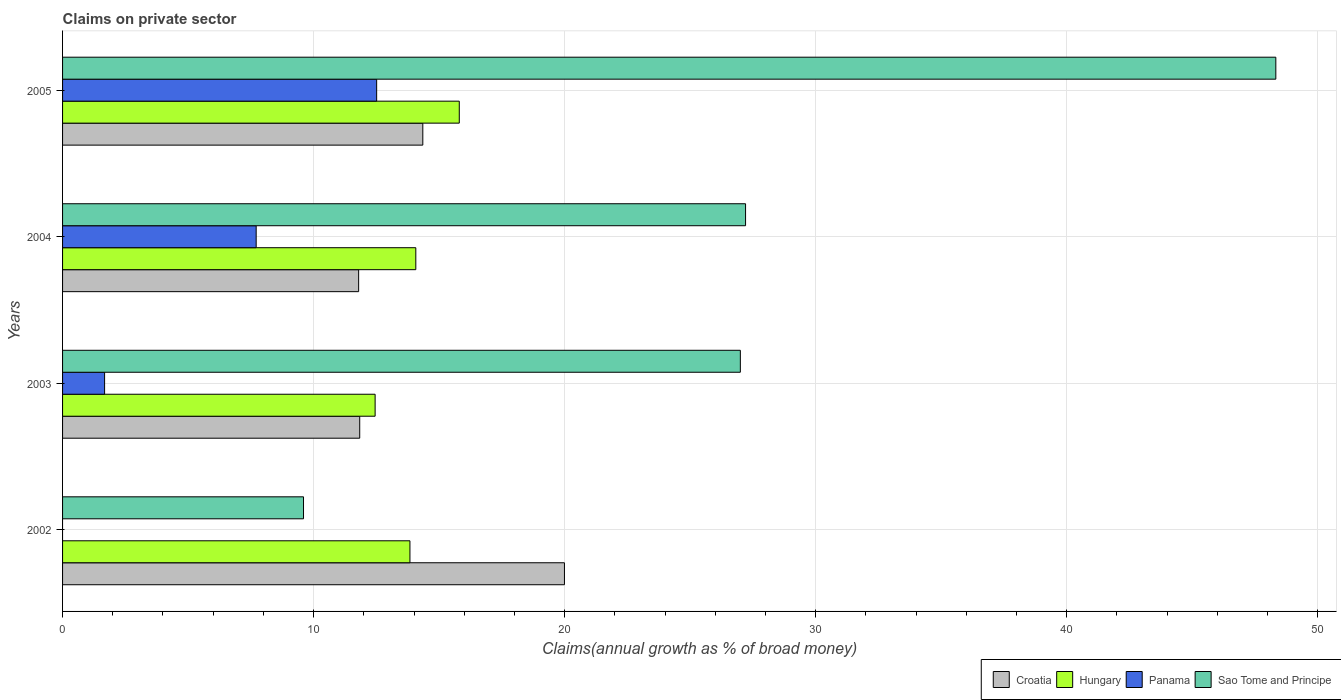Are the number of bars per tick equal to the number of legend labels?
Keep it short and to the point. No. Are the number of bars on each tick of the Y-axis equal?
Provide a succinct answer. No. How many bars are there on the 3rd tick from the bottom?
Your answer should be very brief. 4. What is the percentage of broad money claimed on private sector in Sao Tome and Principe in 2005?
Give a very brief answer. 48.33. Across all years, what is the maximum percentage of broad money claimed on private sector in Croatia?
Offer a very short reply. 19.99. Across all years, what is the minimum percentage of broad money claimed on private sector in Croatia?
Your response must be concise. 11.8. In which year was the percentage of broad money claimed on private sector in Croatia maximum?
Your answer should be compact. 2002. What is the total percentage of broad money claimed on private sector in Hungary in the graph?
Offer a terse response. 56.17. What is the difference between the percentage of broad money claimed on private sector in Panama in 2004 and that in 2005?
Keep it short and to the point. -4.8. What is the difference between the percentage of broad money claimed on private sector in Sao Tome and Principe in 2005 and the percentage of broad money claimed on private sector in Panama in 2002?
Offer a very short reply. 48.33. What is the average percentage of broad money claimed on private sector in Sao Tome and Principe per year?
Keep it short and to the point. 28.04. In the year 2002, what is the difference between the percentage of broad money claimed on private sector in Croatia and percentage of broad money claimed on private sector in Hungary?
Ensure brevity in your answer.  6.16. What is the ratio of the percentage of broad money claimed on private sector in Sao Tome and Principe in 2002 to that in 2005?
Provide a short and direct response. 0.2. Is the difference between the percentage of broad money claimed on private sector in Croatia in 2002 and 2004 greater than the difference between the percentage of broad money claimed on private sector in Hungary in 2002 and 2004?
Offer a very short reply. Yes. What is the difference between the highest and the second highest percentage of broad money claimed on private sector in Hungary?
Ensure brevity in your answer.  1.73. What is the difference between the highest and the lowest percentage of broad money claimed on private sector in Hungary?
Make the answer very short. 3.35. In how many years, is the percentage of broad money claimed on private sector in Sao Tome and Principe greater than the average percentage of broad money claimed on private sector in Sao Tome and Principe taken over all years?
Make the answer very short. 1. Is it the case that in every year, the sum of the percentage of broad money claimed on private sector in Panama and percentage of broad money claimed on private sector in Sao Tome and Principe is greater than the sum of percentage of broad money claimed on private sector in Croatia and percentage of broad money claimed on private sector in Hungary?
Provide a succinct answer. No. Is it the case that in every year, the sum of the percentage of broad money claimed on private sector in Hungary and percentage of broad money claimed on private sector in Sao Tome and Principe is greater than the percentage of broad money claimed on private sector in Panama?
Offer a very short reply. Yes. Are all the bars in the graph horizontal?
Make the answer very short. Yes. How many years are there in the graph?
Your answer should be very brief. 4. What is the difference between two consecutive major ticks on the X-axis?
Your answer should be compact. 10. Does the graph contain grids?
Your answer should be very brief. Yes. How many legend labels are there?
Your answer should be very brief. 4. How are the legend labels stacked?
Your answer should be very brief. Horizontal. What is the title of the graph?
Make the answer very short. Claims on private sector. What is the label or title of the X-axis?
Your answer should be compact. Claims(annual growth as % of broad money). What is the label or title of the Y-axis?
Keep it short and to the point. Years. What is the Claims(annual growth as % of broad money) in Croatia in 2002?
Offer a terse response. 19.99. What is the Claims(annual growth as % of broad money) of Hungary in 2002?
Make the answer very short. 13.84. What is the Claims(annual growth as % of broad money) in Panama in 2002?
Your answer should be compact. 0. What is the Claims(annual growth as % of broad money) of Sao Tome and Principe in 2002?
Keep it short and to the point. 9.6. What is the Claims(annual growth as % of broad money) of Croatia in 2003?
Your answer should be very brief. 11.84. What is the Claims(annual growth as % of broad money) of Hungary in 2003?
Provide a succinct answer. 12.45. What is the Claims(annual growth as % of broad money) in Panama in 2003?
Make the answer very short. 1.67. What is the Claims(annual growth as % of broad money) of Sao Tome and Principe in 2003?
Your answer should be compact. 27. What is the Claims(annual growth as % of broad money) in Croatia in 2004?
Keep it short and to the point. 11.8. What is the Claims(annual growth as % of broad money) of Hungary in 2004?
Give a very brief answer. 14.07. What is the Claims(annual growth as % of broad money) of Panama in 2004?
Ensure brevity in your answer.  7.71. What is the Claims(annual growth as % of broad money) in Sao Tome and Principe in 2004?
Make the answer very short. 27.21. What is the Claims(annual growth as % of broad money) in Croatia in 2005?
Your answer should be compact. 14.35. What is the Claims(annual growth as % of broad money) in Hungary in 2005?
Make the answer very short. 15.8. What is the Claims(annual growth as % of broad money) in Panama in 2005?
Provide a short and direct response. 12.51. What is the Claims(annual growth as % of broad money) of Sao Tome and Principe in 2005?
Provide a short and direct response. 48.33. Across all years, what is the maximum Claims(annual growth as % of broad money) of Croatia?
Offer a terse response. 19.99. Across all years, what is the maximum Claims(annual growth as % of broad money) in Hungary?
Offer a very short reply. 15.8. Across all years, what is the maximum Claims(annual growth as % of broad money) in Panama?
Provide a succinct answer. 12.51. Across all years, what is the maximum Claims(annual growth as % of broad money) in Sao Tome and Principe?
Provide a succinct answer. 48.33. Across all years, what is the minimum Claims(annual growth as % of broad money) of Croatia?
Your answer should be compact. 11.8. Across all years, what is the minimum Claims(annual growth as % of broad money) of Hungary?
Your answer should be compact. 12.45. Across all years, what is the minimum Claims(annual growth as % of broad money) in Panama?
Ensure brevity in your answer.  0. Across all years, what is the minimum Claims(annual growth as % of broad money) of Sao Tome and Principe?
Your response must be concise. 9.6. What is the total Claims(annual growth as % of broad money) in Croatia in the graph?
Ensure brevity in your answer.  57.98. What is the total Claims(annual growth as % of broad money) of Hungary in the graph?
Give a very brief answer. 56.17. What is the total Claims(annual growth as % of broad money) of Panama in the graph?
Your response must be concise. 21.9. What is the total Claims(annual growth as % of broad money) of Sao Tome and Principe in the graph?
Provide a short and direct response. 112.14. What is the difference between the Claims(annual growth as % of broad money) of Croatia in 2002 and that in 2003?
Keep it short and to the point. 8.16. What is the difference between the Claims(annual growth as % of broad money) in Hungary in 2002 and that in 2003?
Your answer should be compact. 1.39. What is the difference between the Claims(annual growth as % of broad money) of Sao Tome and Principe in 2002 and that in 2003?
Your answer should be very brief. -17.4. What is the difference between the Claims(annual growth as % of broad money) in Croatia in 2002 and that in 2004?
Provide a succinct answer. 8.2. What is the difference between the Claims(annual growth as % of broad money) in Hungary in 2002 and that in 2004?
Provide a succinct answer. -0.23. What is the difference between the Claims(annual growth as % of broad money) in Sao Tome and Principe in 2002 and that in 2004?
Provide a short and direct response. -17.61. What is the difference between the Claims(annual growth as % of broad money) of Croatia in 2002 and that in 2005?
Provide a short and direct response. 5.64. What is the difference between the Claims(annual growth as % of broad money) in Hungary in 2002 and that in 2005?
Offer a terse response. -1.97. What is the difference between the Claims(annual growth as % of broad money) in Sao Tome and Principe in 2002 and that in 2005?
Keep it short and to the point. -38.73. What is the difference between the Claims(annual growth as % of broad money) in Croatia in 2003 and that in 2004?
Your answer should be compact. 0.04. What is the difference between the Claims(annual growth as % of broad money) of Hungary in 2003 and that in 2004?
Offer a very short reply. -1.62. What is the difference between the Claims(annual growth as % of broad money) in Panama in 2003 and that in 2004?
Make the answer very short. -6.04. What is the difference between the Claims(annual growth as % of broad money) of Sao Tome and Principe in 2003 and that in 2004?
Keep it short and to the point. -0.21. What is the difference between the Claims(annual growth as % of broad money) of Croatia in 2003 and that in 2005?
Provide a succinct answer. -2.51. What is the difference between the Claims(annual growth as % of broad money) of Hungary in 2003 and that in 2005?
Provide a succinct answer. -3.35. What is the difference between the Claims(annual growth as % of broad money) in Panama in 2003 and that in 2005?
Offer a terse response. -10.84. What is the difference between the Claims(annual growth as % of broad money) of Sao Tome and Principe in 2003 and that in 2005?
Give a very brief answer. -21.33. What is the difference between the Claims(annual growth as % of broad money) of Croatia in 2004 and that in 2005?
Give a very brief answer. -2.56. What is the difference between the Claims(annual growth as % of broad money) in Hungary in 2004 and that in 2005?
Offer a terse response. -1.73. What is the difference between the Claims(annual growth as % of broad money) in Panama in 2004 and that in 2005?
Provide a succinct answer. -4.8. What is the difference between the Claims(annual growth as % of broad money) in Sao Tome and Principe in 2004 and that in 2005?
Make the answer very short. -21.12. What is the difference between the Claims(annual growth as % of broad money) in Croatia in 2002 and the Claims(annual growth as % of broad money) in Hungary in 2003?
Your answer should be compact. 7.54. What is the difference between the Claims(annual growth as % of broad money) in Croatia in 2002 and the Claims(annual growth as % of broad money) in Panama in 2003?
Your response must be concise. 18.32. What is the difference between the Claims(annual growth as % of broad money) of Croatia in 2002 and the Claims(annual growth as % of broad money) of Sao Tome and Principe in 2003?
Make the answer very short. -7.01. What is the difference between the Claims(annual growth as % of broad money) in Hungary in 2002 and the Claims(annual growth as % of broad money) in Panama in 2003?
Keep it short and to the point. 12.16. What is the difference between the Claims(annual growth as % of broad money) of Hungary in 2002 and the Claims(annual growth as % of broad money) of Sao Tome and Principe in 2003?
Give a very brief answer. -13.16. What is the difference between the Claims(annual growth as % of broad money) in Croatia in 2002 and the Claims(annual growth as % of broad money) in Hungary in 2004?
Provide a succinct answer. 5.92. What is the difference between the Claims(annual growth as % of broad money) of Croatia in 2002 and the Claims(annual growth as % of broad money) of Panama in 2004?
Make the answer very short. 12.28. What is the difference between the Claims(annual growth as % of broad money) in Croatia in 2002 and the Claims(annual growth as % of broad money) in Sao Tome and Principe in 2004?
Offer a terse response. -7.21. What is the difference between the Claims(annual growth as % of broad money) in Hungary in 2002 and the Claims(annual growth as % of broad money) in Panama in 2004?
Provide a short and direct response. 6.13. What is the difference between the Claims(annual growth as % of broad money) of Hungary in 2002 and the Claims(annual growth as % of broad money) of Sao Tome and Principe in 2004?
Give a very brief answer. -13.37. What is the difference between the Claims(annual growth as % of broad money) in Croatia in 2002 and the Claims(annual growth as % of broad money) in Hungary in 2005?
Ensure brevity in your answer.  4.19. What is the difference between the Claims(annual growth as % of broad money) in Croatia in 2002 and the Claims(annual growth as % of broad money) in Panama in 2005?
Offer a terse response. 7.48. What is the difference between the Claims(annual growth as % of broad money) of Croatia in 2002 and the Claims(annual growth as % of broad money) of Sao Tome and Principe in 2005?
Offer a terse response. -28.34. What is the difference between the Claims(annual growth as % of broad money) of Hungary in 2002 and the Claims(annual growth as % of broad money) of Panama in 2005?
Give a very brief answer. 1.33. What is the difference between the Claims(annual growth as % of broad money) of Hungary in 2002 and the Claims(annual growth as % of broad money) of Sao Tome and Principe in 2005?
Provide a short and direct response. -34.49. What is the difference between the Claims(annual growth as % of broad money) in Croatia in 2003 and the Claims(annual growth as % of broad money) in Hungary in 2004?
Your answer should be compact. -2.23. What is the difference between the Claims(annual growth as % of broad money) of Croatia in 2003 and the Claims(annual growth as % of broad money) of Panama in 2004?
Offer a very short reply. 4.13. What is the difference between the Claims(annual growth as % of broad money) of Croatia in 2003 and the Claims(annual growth as % of broad money) of Sao Tome and Principe in 2004?
Make the answer very short. -15.37. What is the difference between the Claims(annual growth as % of broad money) in Hungary in 2003 and the Claims(annual growth as % of broad money) in Panama in 2004?
Your answer should be very brief. 4.74. What is the difference between the Claims(annual growth as % of broad money) of Hungary in 2003 and the Claims(annual growth as % of broad money) of Sao Tome and Principe in 2004?
Your answer should be compact. -14.76. What is the difference between the Claims(annual growth as % of broad money) in Panama in 2003 and the Claims(annual growth as % of broad money) in Sao Tome and Principe in 2004?
Offer a very short reply. -25.53. What is the difference between the Claims(annual growth as % of broad money) of Croatia in 2003 and the Claims(annual growth as % of broad money) of Hungary in 2005?
Offer a very short reply. -3.97. What is the difference between the Claims(annual growth as % of broad money) of Croatia in 2003 and the Claims(annual growth as % of broad money) of Panama in 2005?
Make the answer very short. -0.67. What is the difference between the Claims(annual growth as % of broad money) of Croatia in 2003 and the Claims(annual growth as % of broad money) of Sao Tome and Principe in 2005?
Give a very brief answer. -36.5. What is the difference between the Claims(annual growth as % of broad money) in Hungary in 2003 and the Claims(annual growth as % of broad money) in Panama in 2005?
Your response must be concise. -0.06. What is the difference between the Claims(annual growth as % of broad money) in Hungary in 2003 and the Claims(annual growth as % of broad money) in Sao Tome and Principe in 2005?
Your response must be concise. -35.88. What is the difference between the Claims(annual growth as % of broad money) in Panama in 2003 and the Claims(annual growth as % of broad money) in Sao Tome and Principe in 2005?
Provide a succinct answer. -46.66. What is the difference between the Claims(annual growth as % of broad money) in Croatia in 2004 and the Claims(annual growth as % of broad money) in Hungary in 2005?
Offer a very short reply. -4.01. What is the difference between the Claims(annual growth as % of broad money) of Croatia in 2004 and the Claims(annual growth as % of broad money) of Panama in 2005?
Your answer should be compact. -0.72. What is the difference between the Claims(annual growth as % of broad money) of Croatia in 2004 and the Claims(annual growth as % of broad money) of Sao Tome and Principe in 2005?
Provide a short and direct response. -36.54. What is the difference between the Claims(annual growth as % of broad money) in Hungary in 2004 and the Claims(annual growth as % of broad money) in Panama in 2005?
Your response must be concise. 1.56. What is the difference between the Claims(annual growth as % of broad money) in Hungary in 2004 and the Claims(annual growth as % of broad money) in Sao Tome and Principe in 2005?
Make the answer very short. -34.26. What is the difference between the Claims(annual growth as % of broad money) of Panama in 2004 and the Claims(annual growth as % of broad money) of Sao Tome and Principe in 2005?
Your answer should be very brief. -40.62. What is the average Claims(annual growth as % of broad money) in Croatia per year?
Make the answer very short. 14.49. What is the average Claims(annual growth as % of broad money) in Hungary per year?
Ensure brevity in your answer.  14.04. What is the average Claims(annual growth as % of broad money) in Panama per year?
Offer a very short reply. 5.47. What is the average Claims(annual growth as % of broad money) in Sao Tome and Principe per year?
Give a very brief answer. 28.04. In the year 2002, what is the difference between the Claims(annual growth as % of broad money) in Croatia and Claims(annual growth as % of broad money) in Hungary?
Offer a terse response. 6.16. In the year 2002, what is the difference between the Claims(annual growth as % of broad money) of Croatia and Claims(annual growth as % of broad money) of Sao Tome and Principe?
Provide a succinct answer. 10.39. In the year 2002, what is the difference between the Claims(annual growth as % of broad money) of Hungary and Claims(annual growth as % of broad money) of Sao Tome and Principe?
Give a very brief answer. 4.24. In the year 2003, what is the difference between the Claims(annual growth as % of broad money) of Croatia and Claims(annual growth as % of broad money) of Hungary?
Your answer should be very brief. -0.61. In the year 2003, what is the difference between the Claims(annual growth as % of broad money) in Croatia and Claims(annual growth as % of broad money) in Panama?
Offer a very short reply. 10.16. In the year 2003, what is the difference between the Claims(annual growth as % of broad money) in Croatia and Claims(annual growth as % of broad money) in Sao Tome and Principe?
Your response must be concise. -15.16. In the year 2003, what is the difference between the Claims(annual growth as % of broad money) in Hungary and Claims(annual growth as % of broad money) in Panama?
Ensure brevity in your answer.  10.78. In the year 2003, what is the difference between the Claims(annual growth as % of broad money) in Hungary and Claims(annual growth as % of broad money) in Sao Tome and Principe?
Keep it short and to the point. -14.55. In the year 2003, what is the difference between the Claims(annual growth as % of broad money) of Panama and Claims(annual growth as % of broad money) of Sao Tome and Principe?
Keep it short and to the point. -25.33. In the year 2004, what is the difference between the Claims(annual growth as % of broad money) of Croatia and Claims(annual growth as % of broad money) of Hungary?
Make the answer very short. -2.28. In the year 2004, what is the difference between the Claims(annual growth as % of broad money) in Croatia and Claims(annual growth as % of broad money) in Panama?
Give a very brief answer. 4.08. In the year 2004, what is the difference between the Claims(annual growth as % of broad money) in Croatia and Claims(annual growth as % of broad money) in Sao Tome and Principe?
Your response must be concise. -15.41. In the year 2004, what is the difference between the Claims(annual growth as % of broad money) of Hungary and Claims(annual growth as % of broad money) of Panama?
Provide a short and direct response. 6.36. In the year 2004, what is the difference between the Claims(annual growth as % of broad money) of Hungary and Claims(annual growth as % of broad money) of Sao Tome and Principe?
Your answer should be compact. -13.14. In the year 2004, what is the difference between the Claims(annual growth as % of broad money) in Panama and Claims(annual growth as % of broad money) in Sao Tome and Principe?
Offer a terse response. -19.5. In the year 2005, what is the difference between the Claims(annual growth as % of broad money) in Croatia and Claims(annual growth as % of broad money) in Hungary?
Your answer should be compact. -1.45. In the year 2005, what is the difference between the Claims(annual growth as % of broad money) in Croatia and Claims(annual growth as % of broad money) in Panama?
Provide a short and direct response. 1.84. In the year 2005, what is the difference between the Claims(annual growth as % of broad money) of Croatia and Claims(annual growth as % of broad money) of Sao Tome and Principe?
Keep it short and to the point. -33.98. In the year 2005, what is the difference between the Claims(annual growth as % of broad money) in Hungary and Claims(annual growth as % of broad money) in Panama?
Keep it short and to the point. 3.29. In the year 2005, what is the difference between the Claims(annual growth as % of broad money) in Hungary and Claims(annual growth as % of broad money) in Sao Tome and Principe?
Your response must be concise. -32.53. In the year 2005, what is the difference between the Claims(annual growth as % of broad money) in Panama and Claims(annual growth as % of broad money) in Sao Tome and Principe?
Provide a short and direct response. -35.82. What is the ratio of the Claims(annual growth as % of broad money) of Croatia in 2002 to that in 2003?
Offer a terse response. 1.69. What is the ratio of the Claims(annual growth as % of broad money) of Hungary in 2002 to that in 2003?
Offer a very short reply. 1.11. What is the ratio of the Claims(annual growth as % of broad money) in Sao Tome and Principe in 2002 to that in 2003?
Provide a short and direct response. 0.36. What is the ratio of the Claims(annual growth as % of broad money) of Croatia in 2002 to that in 2004?
Give a very brief answer. 1.7. What is the ratio of the Claims(annual growth as % of broad money) in Hungary in 2002 to that in 2004?
Provide a succinct answer. 0.98. What is the ratio of the Claims(annual growth as % of broad money) in Sao Tome and Principe in 2002 to that in 2004?
Your answer should be compact. 0.35. What is the ratio of the Claims(annual growth as % of broad money) of Croatia in 2002 to that in 2005?
Offer a terse response. 1.39. What is the ratio of the Claims(annual growth as % of broad money) in Hungary in 2002 to that in 2005?
Keep it short and to the point. 0.88. What is the ratio of the Claims(annual growth as % of broad money) of Sao Tome and Principe in 2002 to that in 2005?
Give a very brief answer. 0.2. What is the ratio of the Claims(annual growth as % of broad money) in Hungary in 2003 to that in 2004?
Ensure brevity in your answer.  0.88. What is the ratio of the Claims(annual growth as % of broad money) in Panama in 2003 to that in 2004?
Your response must be concise. 0.22. What is the ratio of the Claims(annual growth as % of broad money) of Croatia in 2003 to that in 2005?
Provide a succinct answer. 0.82. What is the ratio of the Claims(annual growth as % of broad money) of Hungary in 2003 to that in 2005?
Your answer should be compact. 0.79. What is the ratio of the Claims(annual growth as % of broad money) of Panama in 2003 to that in 2005?
Provide a succinct answer. 0.13. What is the ratio of the Claims(annual growth as % of broad money) in Sao Tome and Principe in 2003 to that in 2005?
Provide a succinct answer. 0.56. What is the ratio of the Claims(annual growth as % of broad money) of Croatia in 2004 to that in 2005?
Your answer should be very brief. 0.82. What is the ratio of the Claims(annual growth as % of broad money) of Hungary in 2004 to that in 2005?
Provide a short and direct response. 0.89. What is the ratio of the Claims(annual growth as % of broad money) of Panama in 2004 to that in 2005?
Make the answer very short. 0.62. What is the ratio of the Claims(annual growth as % of broad money) of Sao Tome and Principe in 2004 to that in 2005?
Give a very brief answer. 0.56. What is the difference between the highest and the second highest Claims(annual growth as % of broad money) in Croatia?
Ensure brevity in your answer.  5.64. What is the difference between the highest and the second highest Claims(annual growth as % of broad money) of Hungary?
Provide a succinct answer. 1.73. What is the difference between the highest and the second highest Claims(annual growth as % of broad money) in Sao Tome and Principe?
Your answer should be compact. 21.12. What is the difference between the highest and the lowest Claims(annual growth as % of broad money) in Croatia?
Offer a very short reply. 8.2. What is the difference between the highest and the lowest Claims(annual growth as % of broad money) in Hungary?
Give a very brief answer. 3.35. What is the difference between the highest and the lowest Claims(annual growth as % of broad money) of Panama?
Keep it short and to the point. 12.51. What is the difference between the highest and the lowest Claims(annual growth as % of broad money) in Sao Tome and Principe?
Give a very brief answer. 38.73. 